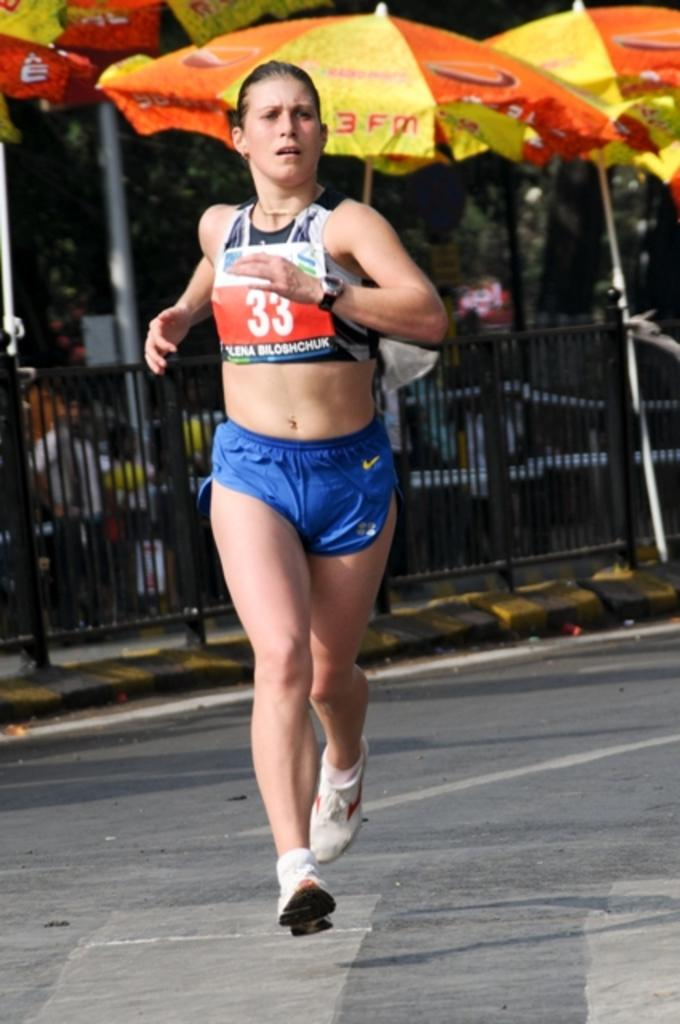Provide a one-sentence caption for the provided image. The runner has the number 33 on her bib. 